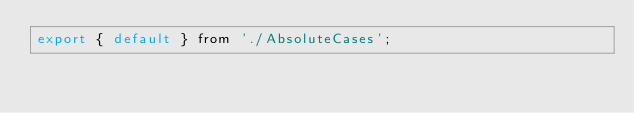<code> <loc_0><loc_0><loc_500><loc_500><_JavaScript_>export { default } from './AbsoluteCases';
</code> 